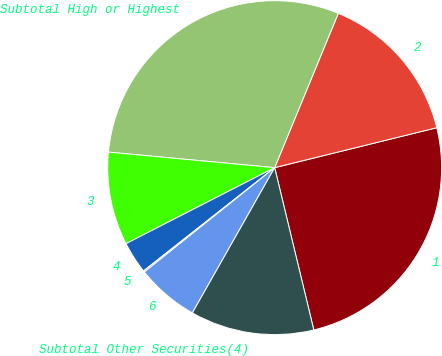<chart> <loc_0><loc_0><loc_500><loc_500><pie_chart><fcel>1<fcel>2<fcel>Subtotal High or Highest<fcel>3<fcel>4<fcel>5<fcel>6<fcel>Subtotal Other Securities(4)<nl><fcel>25.08%<fcel>14.93%<fcel>29.74%<fcel>9.01%<fcel>3.09%<fcel>0.13%<fcel>6.05%<fcel>11.97%<nl></chart> 